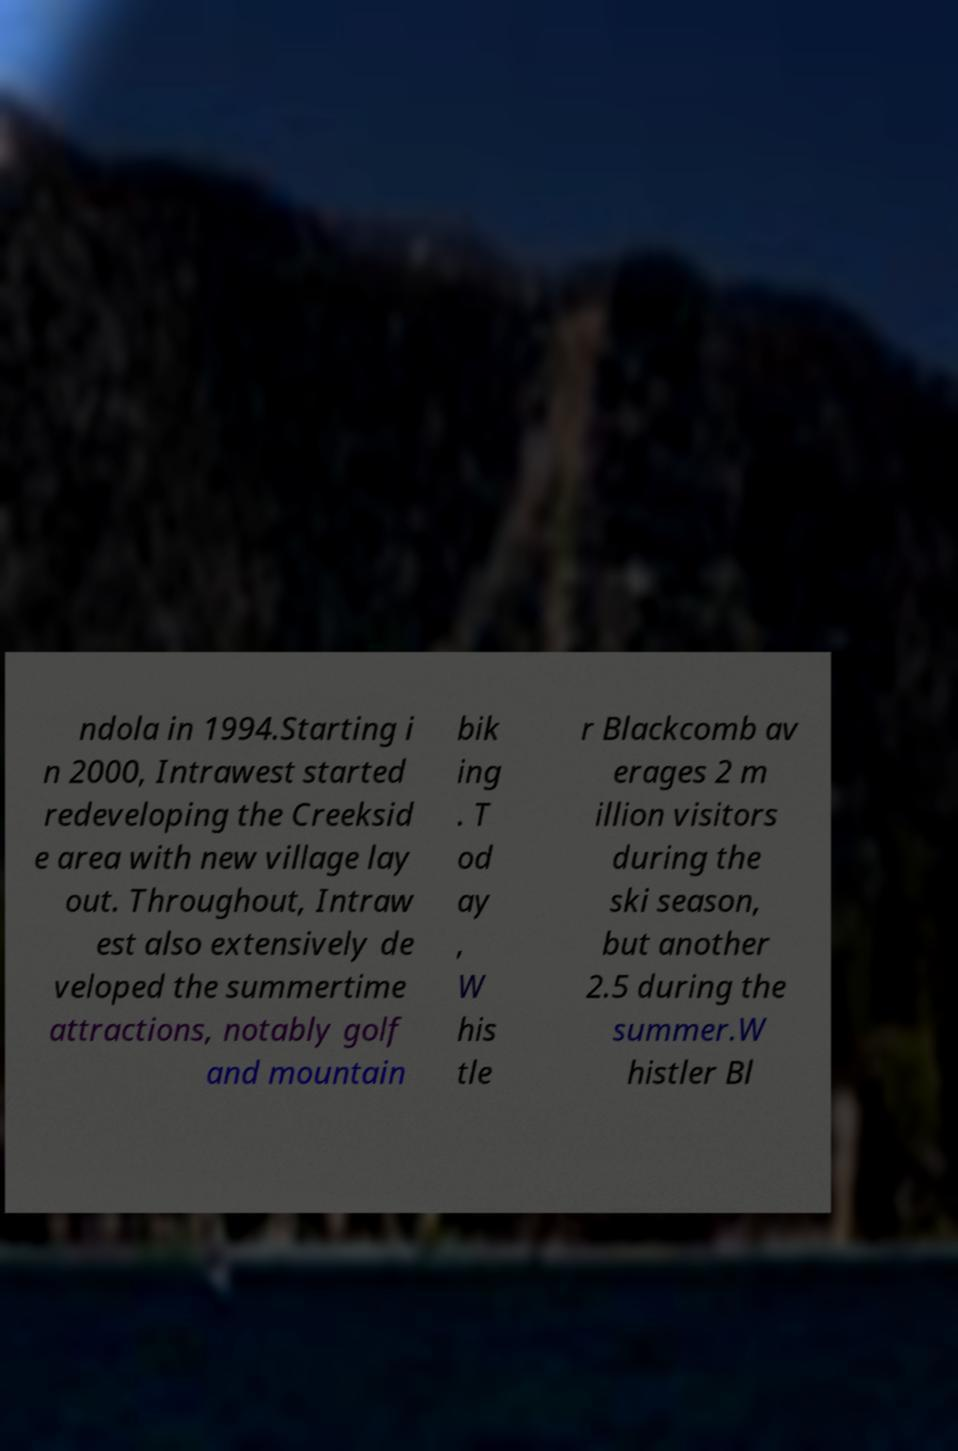Can you read and provide the text displayed in the image?This photo seems to have some interesting text. Can you extract and type it out for me? ndola in 1994.Starting i n 2000, Intrawest started redeveloping the Creeksid e area with new village lay out. Throughout, Intraw est also extensively de veloped the summertime attractions, notably golf and mountain bik ing . T od ay , W his tle r Blackcomb av erages 2 m illion visitors during the ski season, but another 2.5 during the summer.W histler Bl 